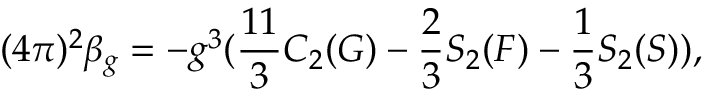Convert formula to latex. <formula><loc_0><loc_0><loc_500><loc_500>( 4 \pi ) ^ { 2 } \beta _ { g } = - g ^ { 3 } ( \frac { 1 1 } { 3 } C _ { 2 } ( G ) - \frac { 2 } { 3 } S _ { 2 } ( F ) - \frac { 1 } { 3 } S _ { 2 } ( S ) ) ,</formula> 